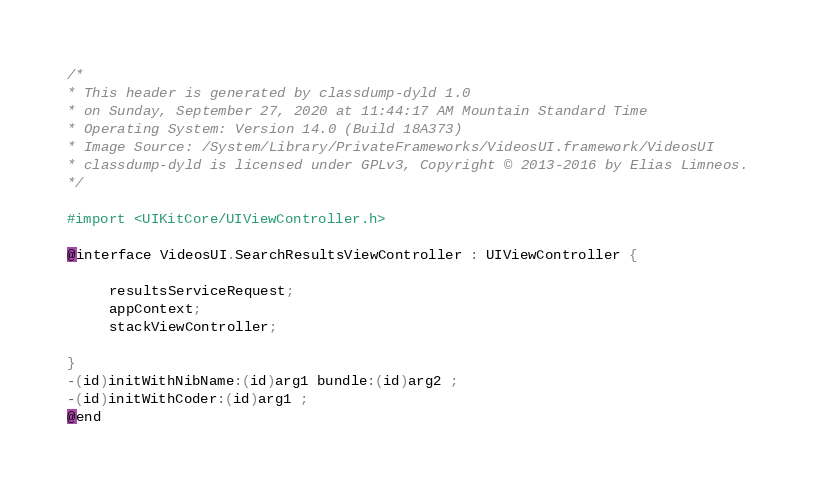<code> <loc_0><loc_0><loc_500><loc_500><_C_>/*
* This header is generated by classdump-dyld 1.0
* on Sunday, September 27, 2020 at 11:44:17 AM Mountain Standard Time
* Operating System: Version 14.0 (Build 18A373)
* Image Source: /System/Library/PrivateFrameworks/VideosUI.framework/VideosUI
* classdump-dyld is licensed under GPLv3, Copyright © 2013-2016 by Elias Limneos.
*/

#import <UIKitCore/UIViewController.h>

@interface VideosUI.SearchResultsViewController : UIViewController {

	 resultsServiceRequest;
	 appContext;
	 stackViewController;

}
-(id)initWithNibName:(id)arg1 bundle:(id)arg2 ;
-(id)initWithCoder:(id)arg1 ;
@end

</code> 